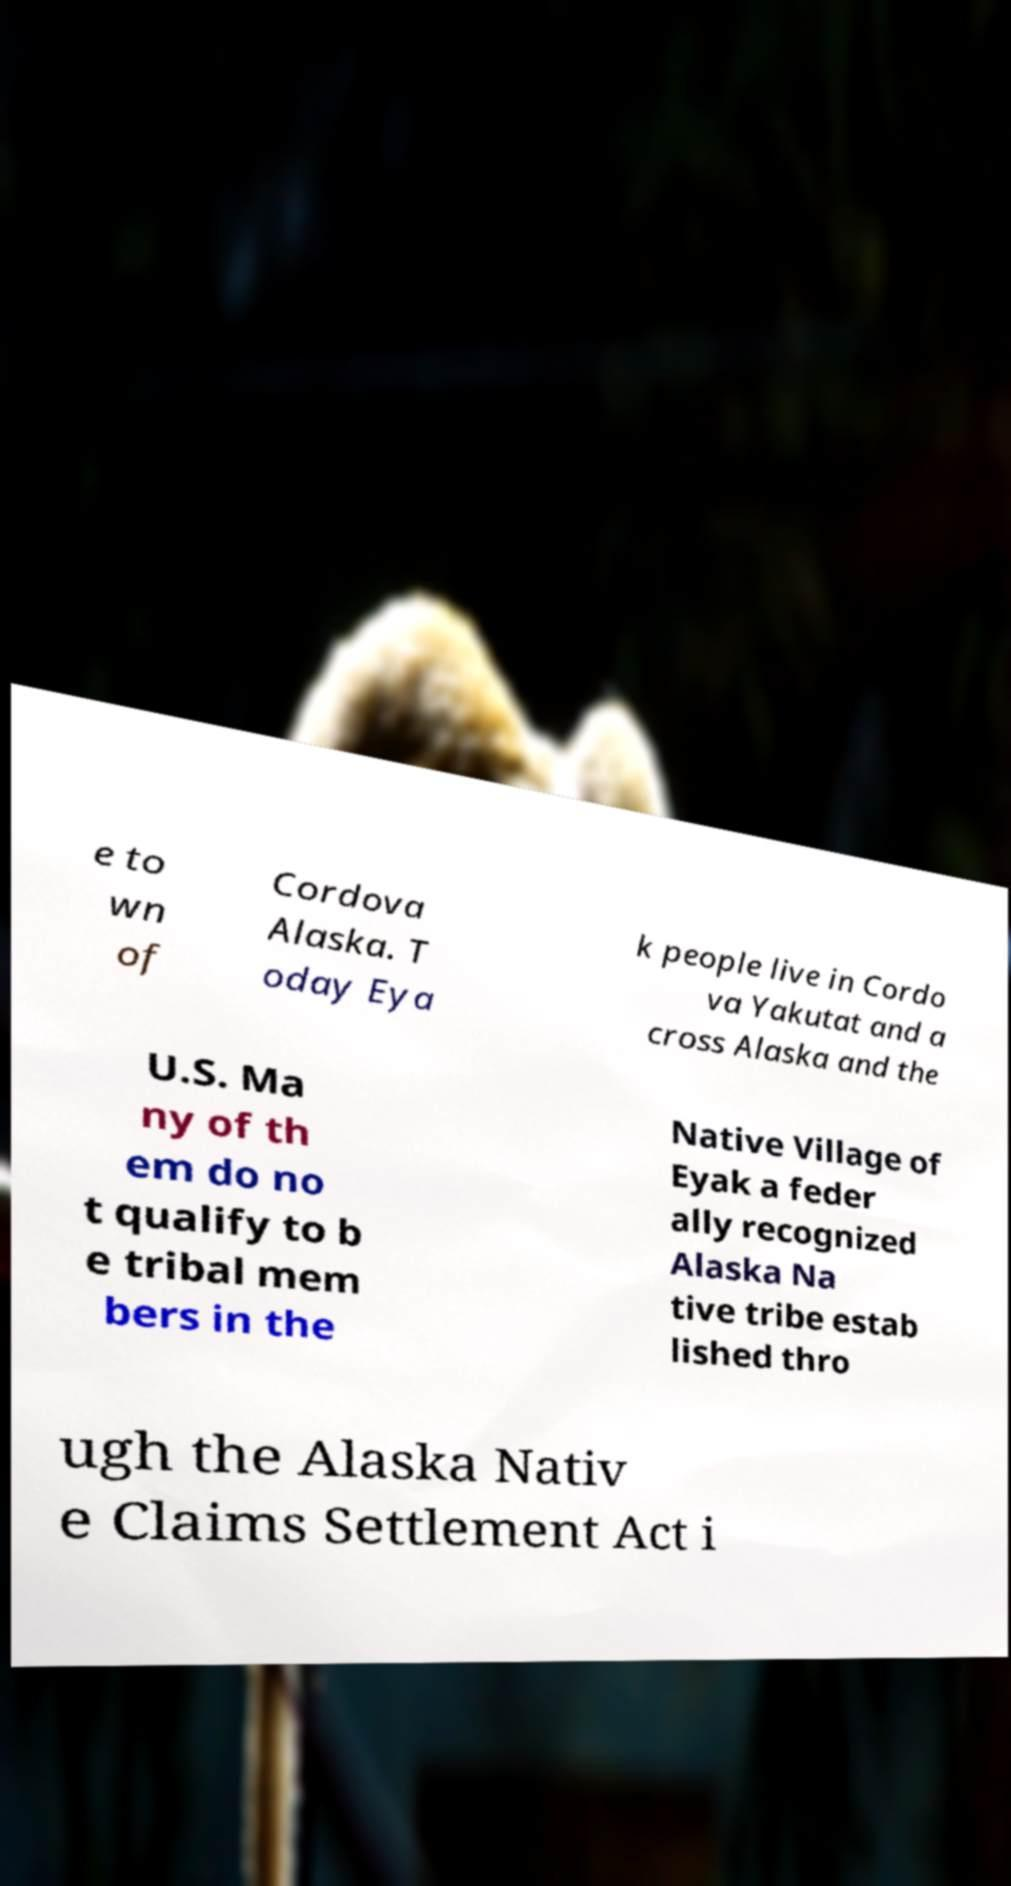What messages or text are displayed in this image? I need them in a readable, typed format. e to wn of Cordova Alaska. T oday Eya k people live in Cordo va Yakutat and a cross Alaska and the U.S. Ma ny of th em do no t qualify to b e tribal mem bers in the Native Village of Eyak a feder ally recognized Alaska Na tive tribe estab lished thro ugh the Alaska Nativ e Claims Settlement Act i 